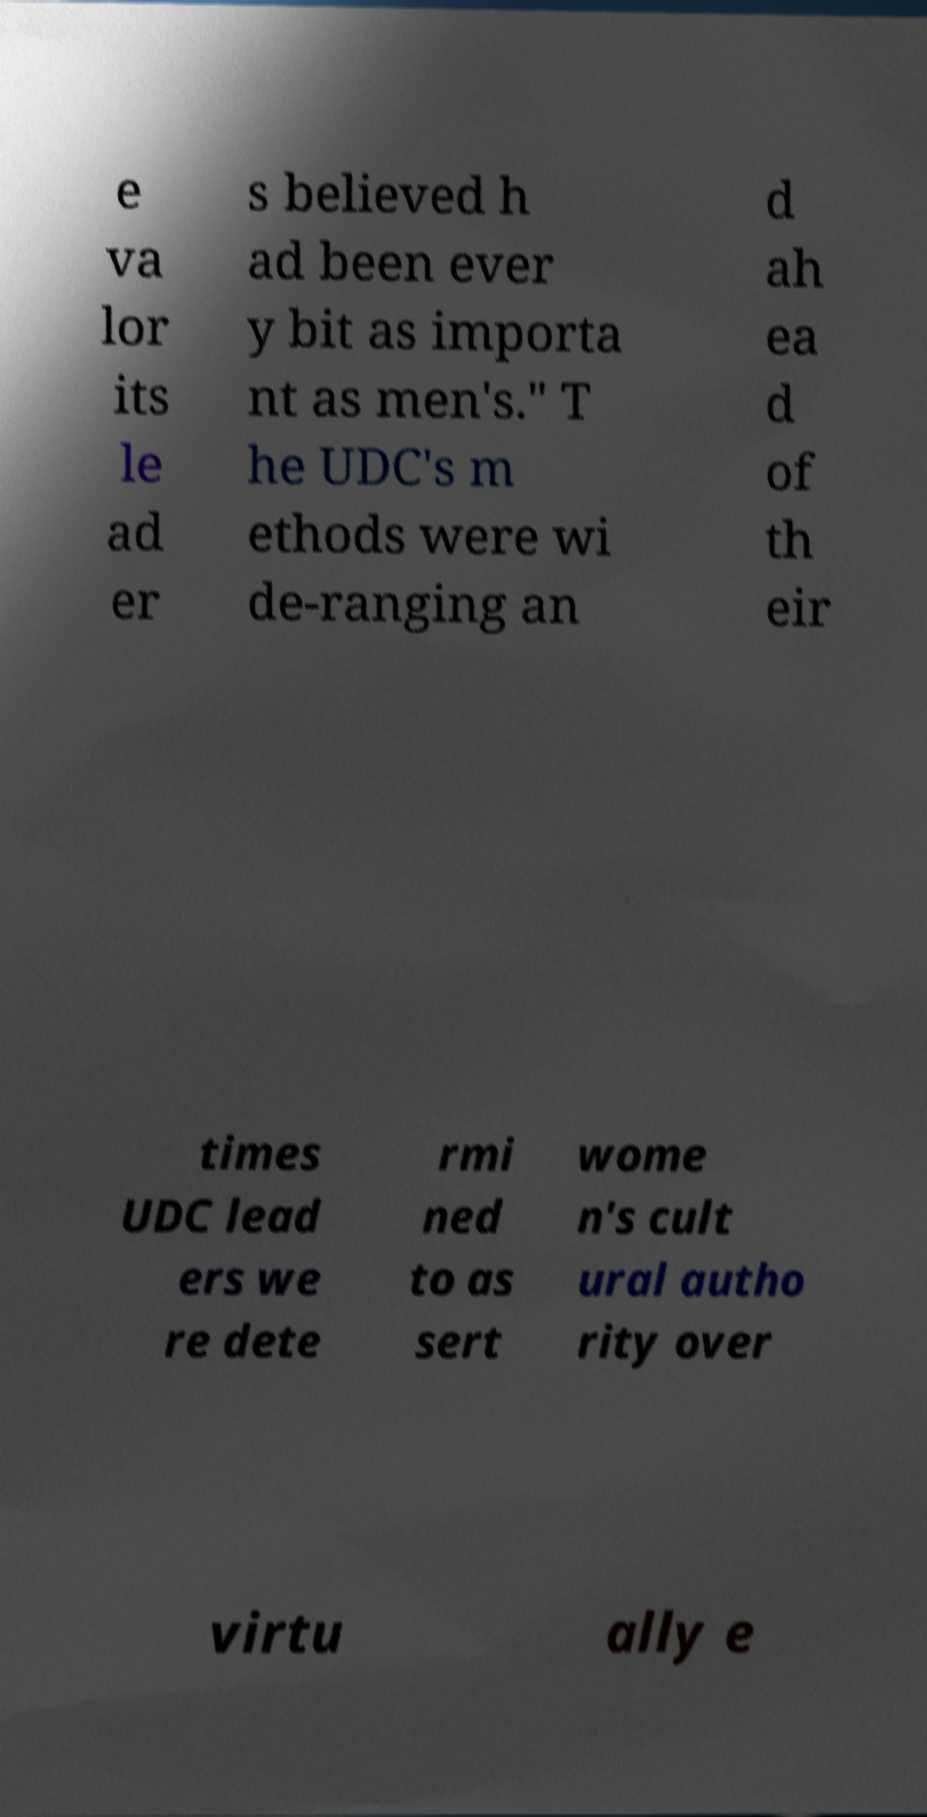Please identify and transcribe the text found in this image. e va lor its le ad er s believed h ad been ever y bit as importa nt as men's." T he UDC's m ethods were wi de-ranging an d ah ea d of th eir times UDC lead ers we re dete rmi ned to as sert wome n's cult ural autho rity over virtu ally e 